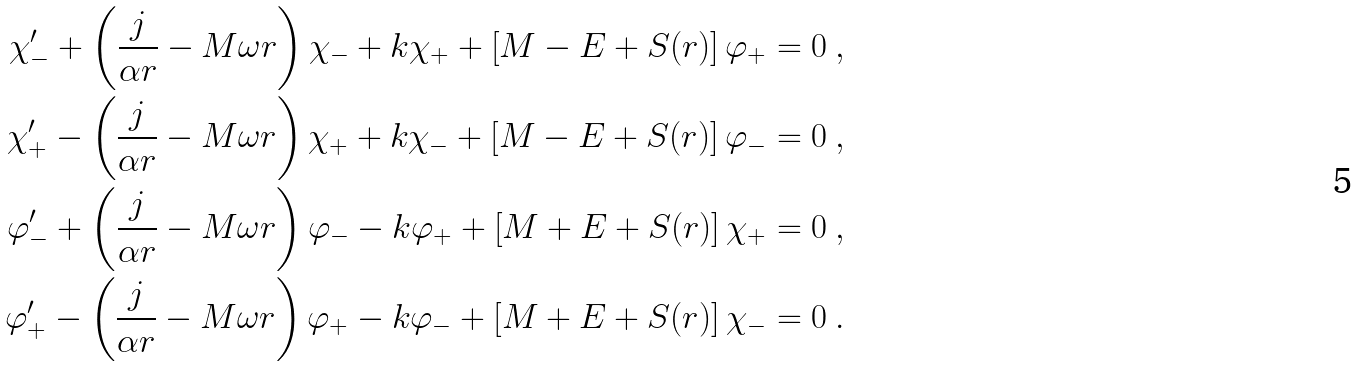Convert formula to latex. <formula><loc_0><loc_0><loc_500><loc_500>\chi _ { - } ^ { \prime } + \left ( \frac { j } { \alpha r } - M \omega r \right ) \chi _ { - } + k \chi _ { + } + \left [ M - E + S ( r ) \right ] \varphi _ { + } & = 0 \ , \\ \chi _ { + } ^ { \prime } - \left ( \frac { j } { \alpha r } - M \omega r \right ) \chi _ { + } + k \chi _ { - } + \left [ M - E + S ( r ) \right ] \varphi _ { - } & = 0 \ , \\ \varphi _ { - } ^ { \prime } + \left ( \frac { j } { \alpha r } - M \omega r \right ) \varphi _ { - } - k \varphi _ { + } + \left [ M + E + S ( r ) \right ] \chi _ { + } & = 0 \ , \\ \varphi _ { + } ^ { \prime } - \left ( \frac { j } { \alpha r } - M \omega r \right ) \varphi _ { + } - k \varphi _ { - } + \left [ M + E + S ( r ) \right ] \chi _ { - } & = 0 \ .</formula> 